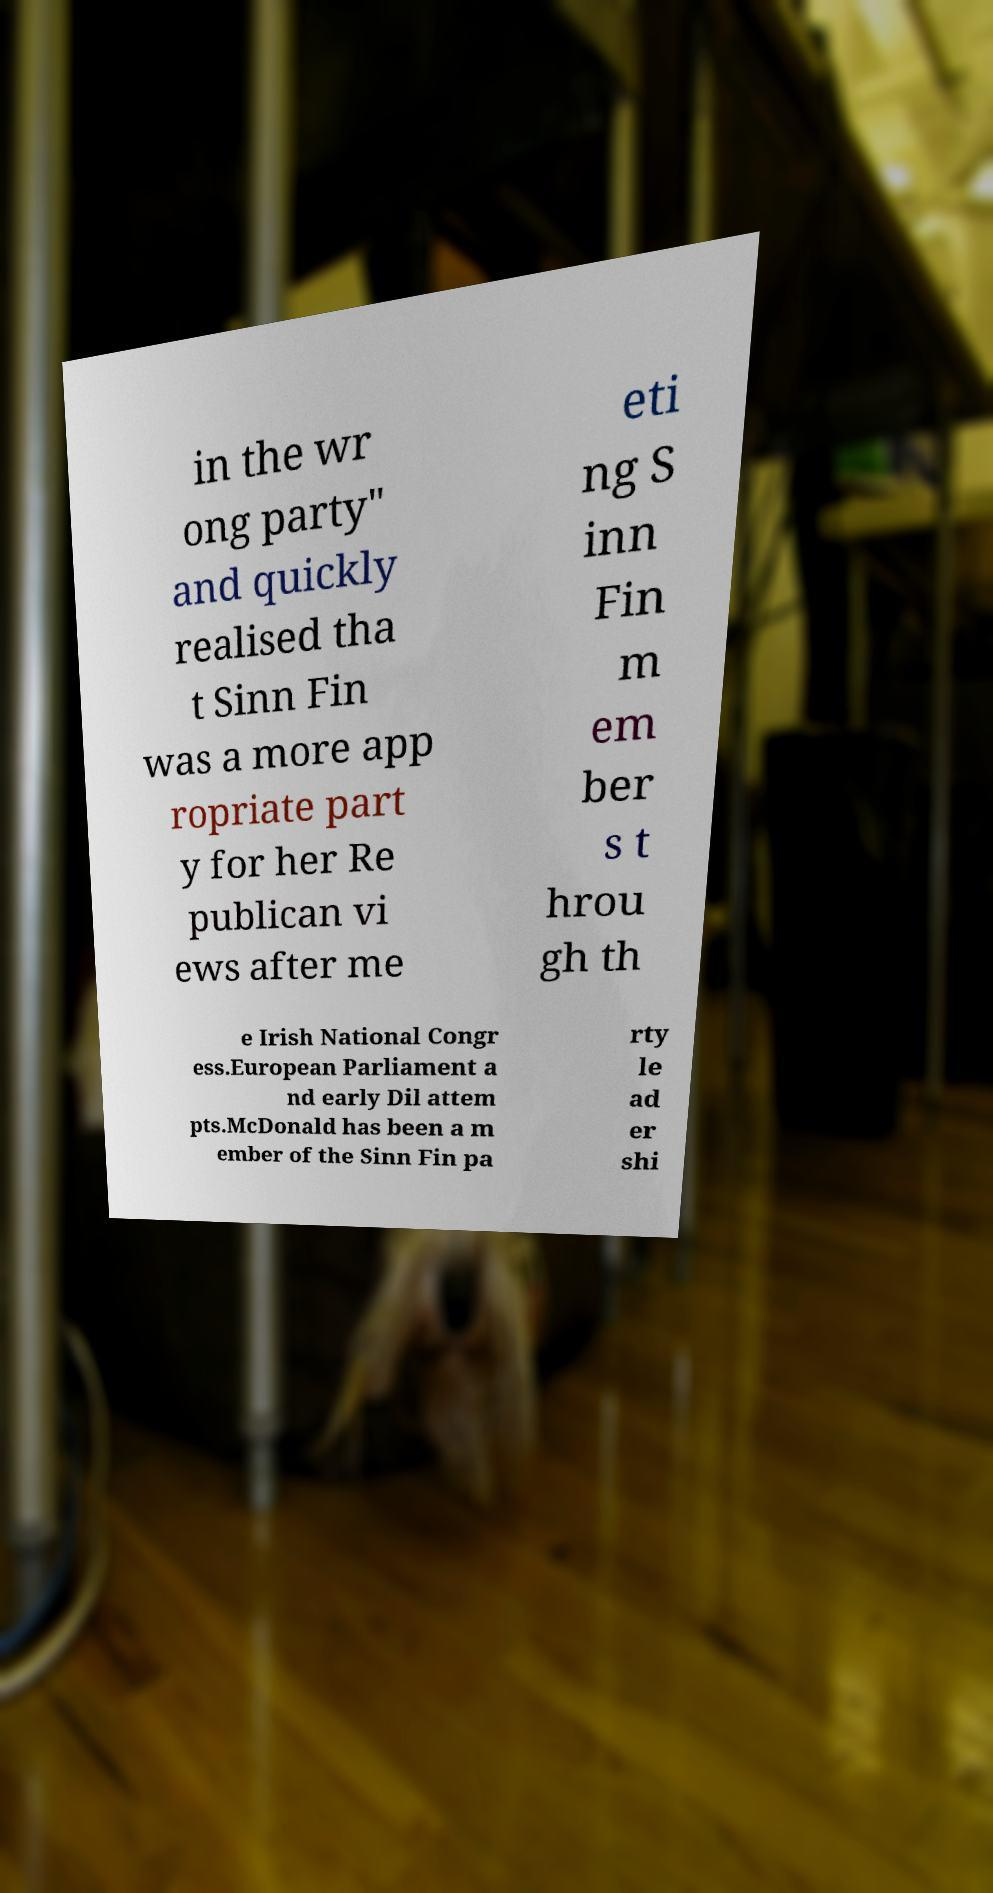Can you accurately transcribe the text from the provided image for me? in the wr ong party" and quickly realised tha t Sinn Fin was a more app ropriate part y for her Re publican vi ews after me eti ng S inn Fin m em ber s t hrou gh th e Irish National Congr ess.European Parliament a nd early Dil attem pts.McDonald has been a m ember of the Sinn Fin pa rty le ad er shi 